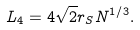Convert formula to latex. <formula><loc_0><loc_0><loc_500><loc_500>L _ { 4 } = 4 \sqrt { 2 } r _ { S } N ^ { 1 / 3 } .</formula> 